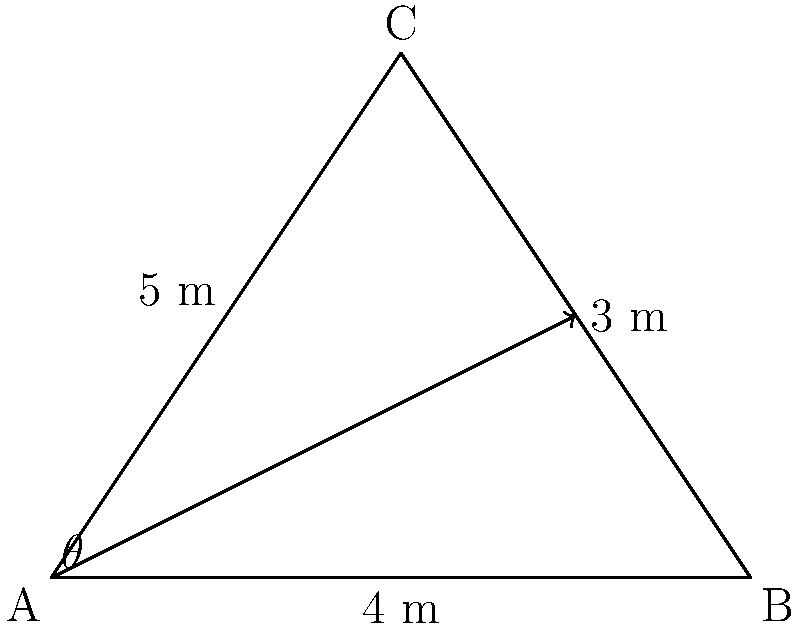In your latest garden design, you've created two intersecting paths forming a triangle ABC. Path AB is 4 meters long, BC is 3 meters, and AC is 5 meters. What is the angle $\theta$ (in degrees) between the two paths that meet at point A? To find the angle $\theta$, we can use the law of cosines. Here's how:

1) The law of cosines states: $c^2 = a^2 + b^2 - 2ab \cos(C)$
   Where $C$ is the angle opposite the side $c$.

2) In our triangle:
   $a = 4$ (side AB)
   $b = 5$ (side AC)
   $c = 3$ (side BC)
   $\theta = $ angle BAC (the angle we're looking for)

3) Rearranging the formula to solve for $\cos(\theta)$:
   $\cos(\theta) = \frac{a^2 + b^2 - c^2}{2ab}$

4) Substituting our values:
   $\cos(\theta) = \frac{4^2 + 5^2 - 3^2}{2(4)(5)}$

5) Simplifying:
   $\cos(\theta) = \frac{16 + 25 - 9}{40} = \frac{32}{40} = 0.8$

6) To get $\theta$, we need to take the inverse cosine (arccos):
   $\theta = \arccos(0.8)$

7) Using a calculator or computer:
   $\theta \approx 36.87°$
Answer: $36.87°$ 